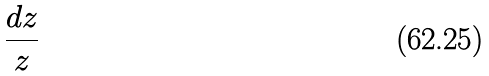<formula> <loc_0><loc_0><loc_500><loc_500>\frac { d z } { z }</formula> 